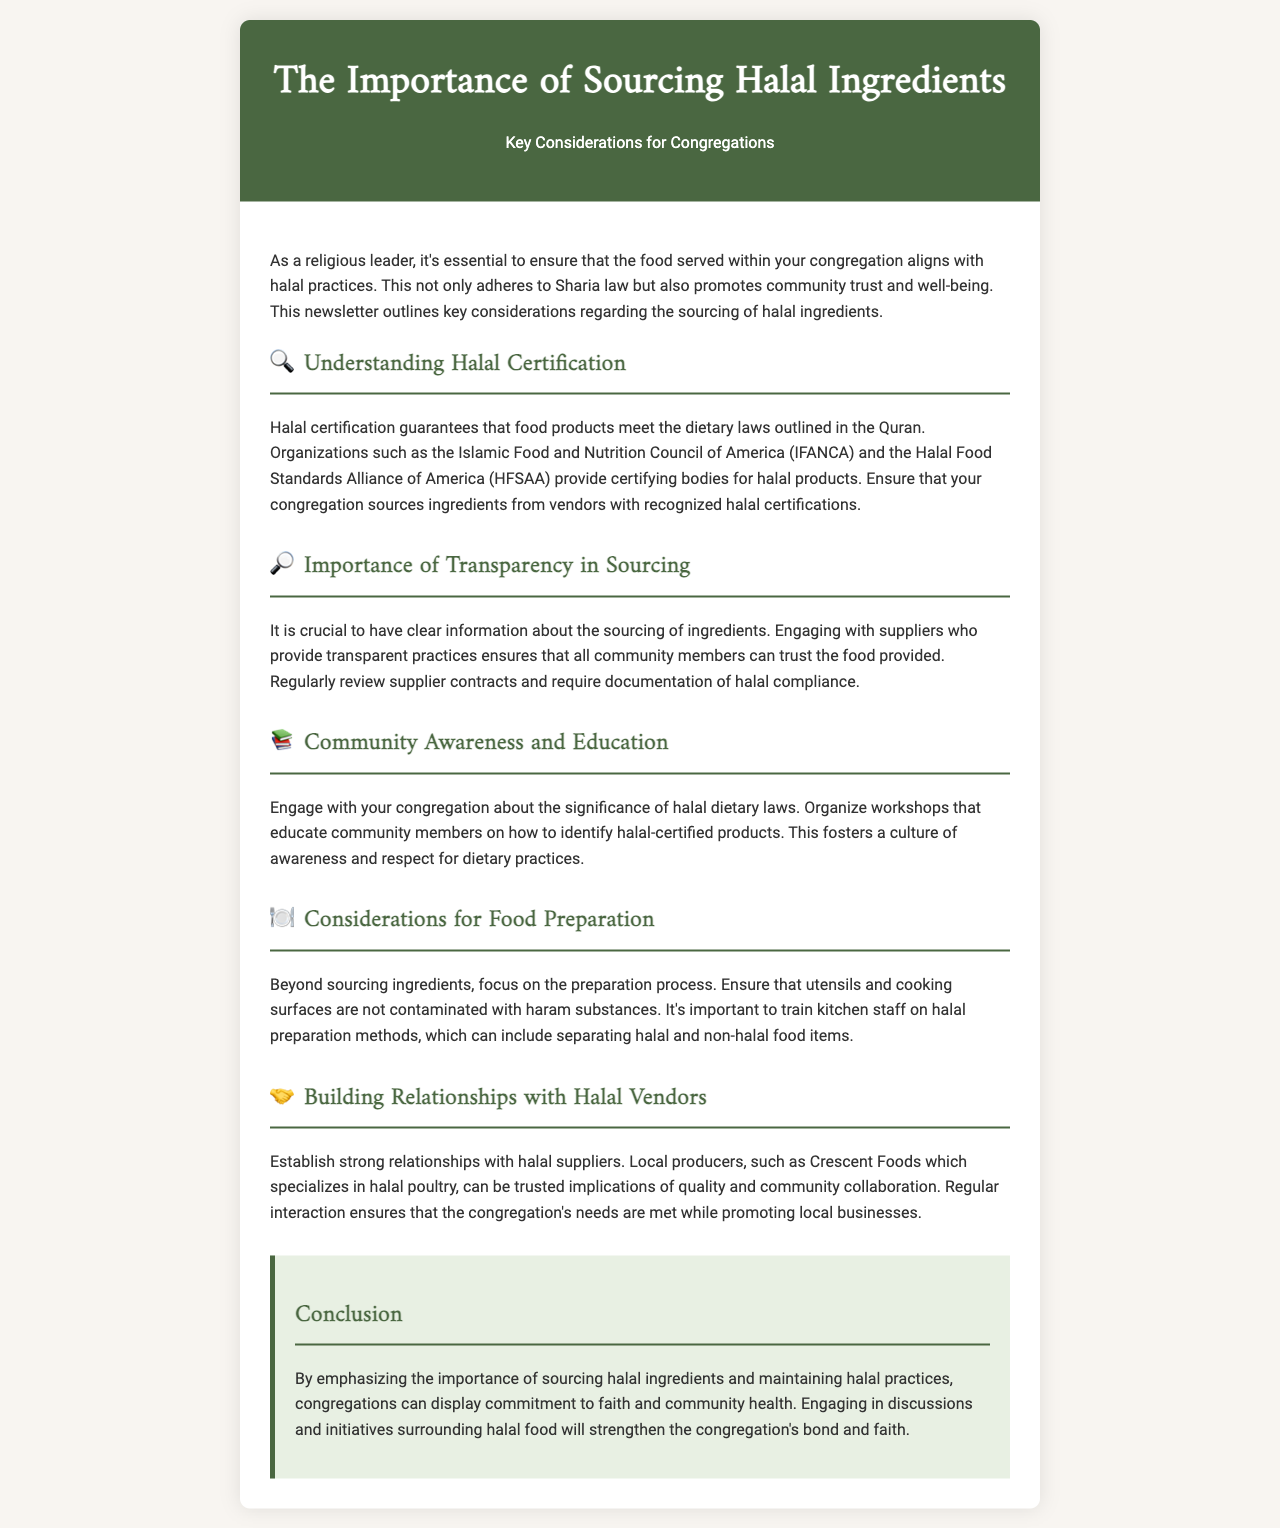What is the title of the newsletter? The title of the newsletter is found at the top of the document.
Answer: The Importance of Sourcing Halal Ingredients Who certifies halal products? The document mentions organizations that certify halal products, specifically named entities.
Answer: Islamic Food and Nutrition Council of America What is a key reason for engaging with suppliers? The importance of clarity in sourcing ingredients is highlighted in the document.
Answer: Trust What does the newsletter suggest to educate the community? The document recommends a specific type of event for community engagement.
Answer: Workshops What type of vendors should congregations build relationships with? The document mentions the kind of vendors to establish relationships with for sourcing.
Answer: Halal suppliers How should food preparation areas be maintained? The document provides a guideline about food preparation practices specific to halal.
Answer: Not contaminated with haram substances What is a local producer mentioned for halal poultry? The document references a specific company known for halal poultry.
Answer: Crescent Foods What should be required from suppliers regarding halal compliance? The newsletter specifies a necessary practice related to documentation in supplier contracts.
Answer: Documentation 